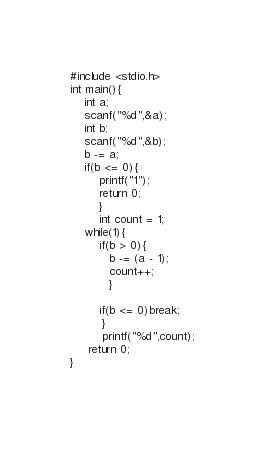Convert code to text. <code><loc_0><loc_0><loc_500><loc_500><_C_>#include <stdio.h>
int main(){
	int a;
	scanf("%d",&a);
	int b;
	scanf("%d",&b);
	b -= a;
	if(b <= 0){
		printf("1");
		return 0;
		}
		int count = 1;
	while(1){
		if(b > 0){
		   b -= (a - 1);
		   count++;
		   }
		   
		if(b <= 0)break;
		 }
		 printf("%d",count);
     return 0;
}
		
</code> 